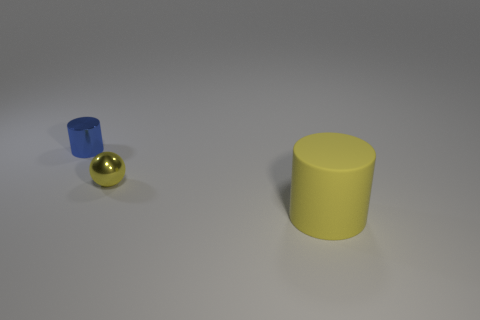Is there anything else that is the same material as the large object?
Make the answer very short. No. Is there any other thing that has the same size as the yellow matte thing?
Your answer should be very brief. No. What number of small shiny balls are the same color as the rubber cylinder?
Make the answer very short. 1. What number of metallic things are there?
Offer a terse response. 2. How many small things are made of the same material as the tiny sphere?
Make the answer very short. 1. There is another object that is the same shape as the big yellow rubber thing; what size is it?
Provide a short and direct response. Small. What is the material of the blue cylinder?
Give a very brief answer. Metal. There is a tiny thing on the right side of the thing left of the small thing in front of the blue shiny object; what is it made of?
Give a very brief answer. Metal. Is there anything else that is the same shape as the yellow metallic thing?
Your answer should be compact. No. What color is the tiny shiny object that is the same shape as the big matte thing?
Give a very brief answer. Blue. 